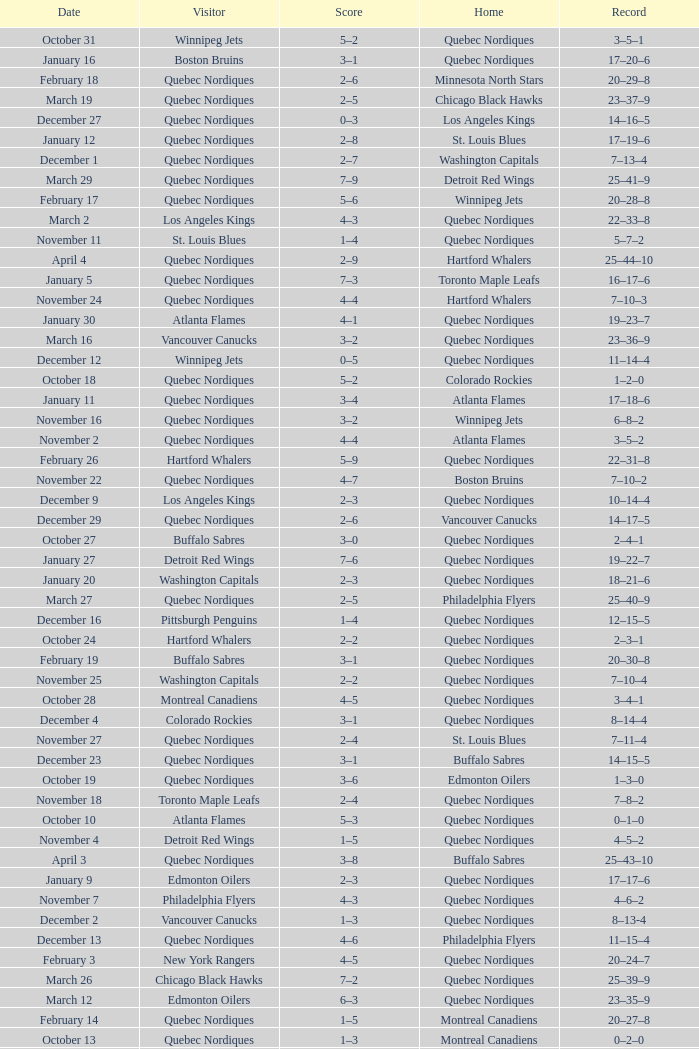Which Home has a Record of 16–17–6? Toronto Maple Leafs. 